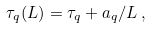<formula> <loc_0><loc_0><loc_500><loc_500>\tau _ { q } ( L ) = \tau _ { q } + a _ { q } / L \, ,</formula> 